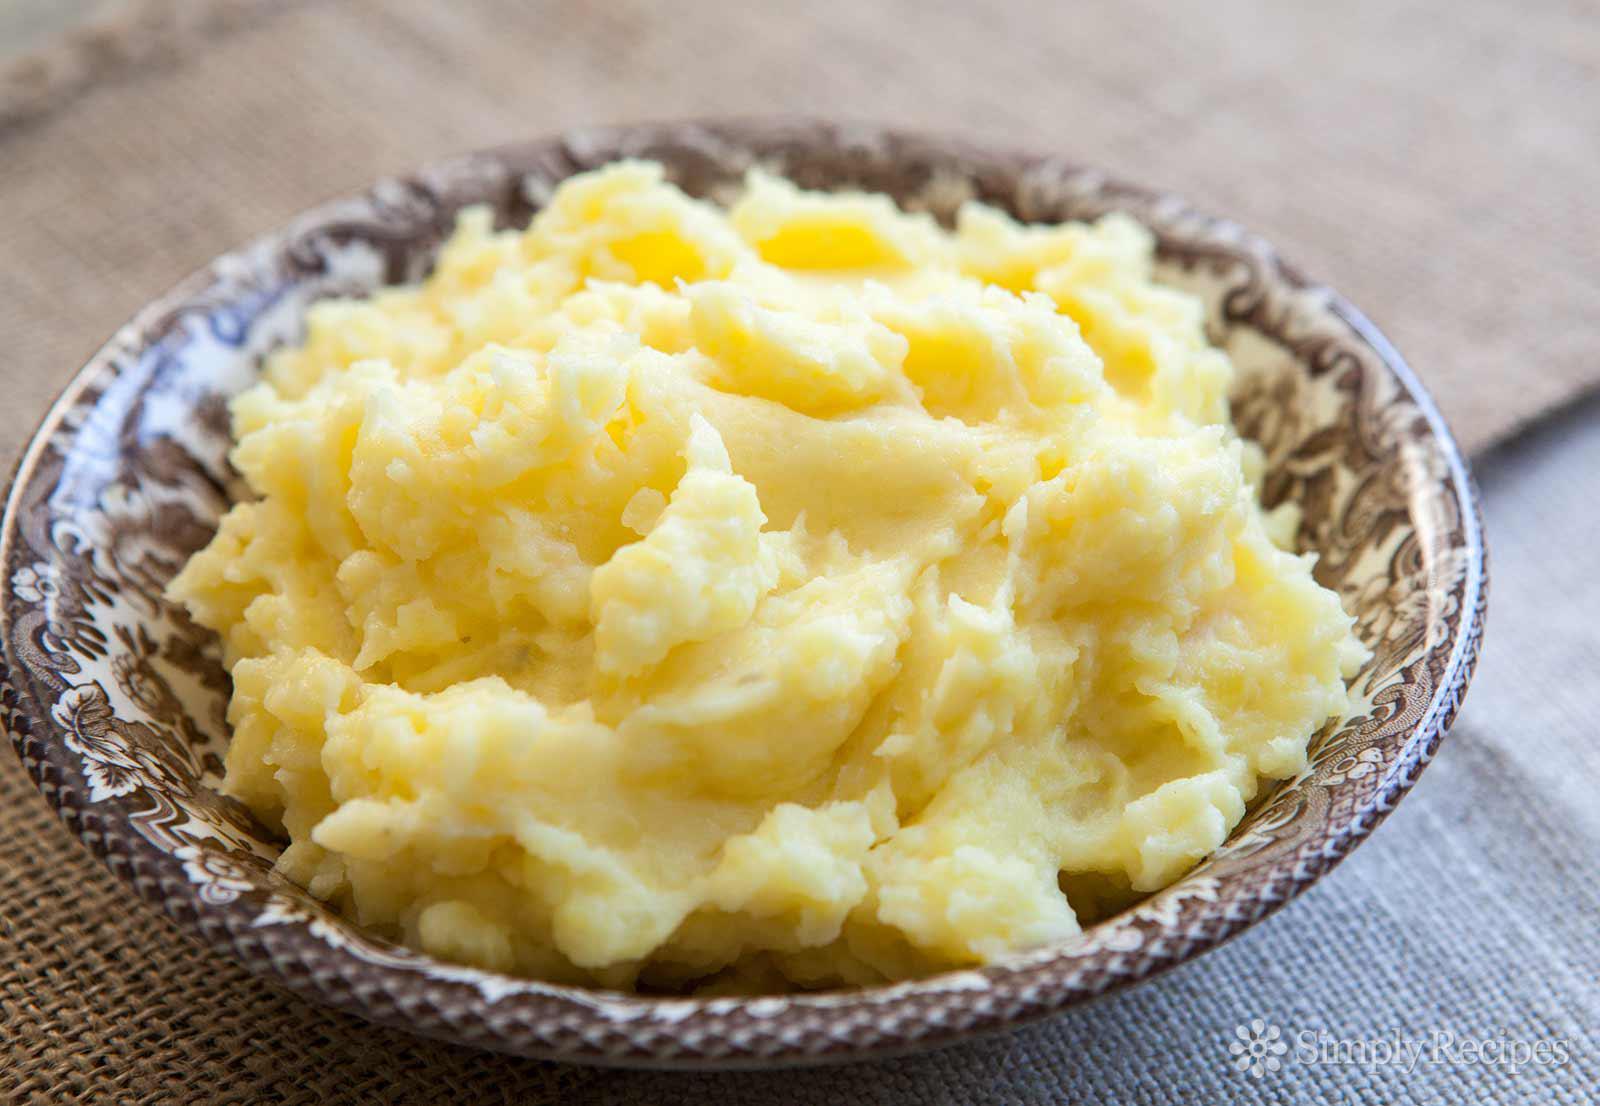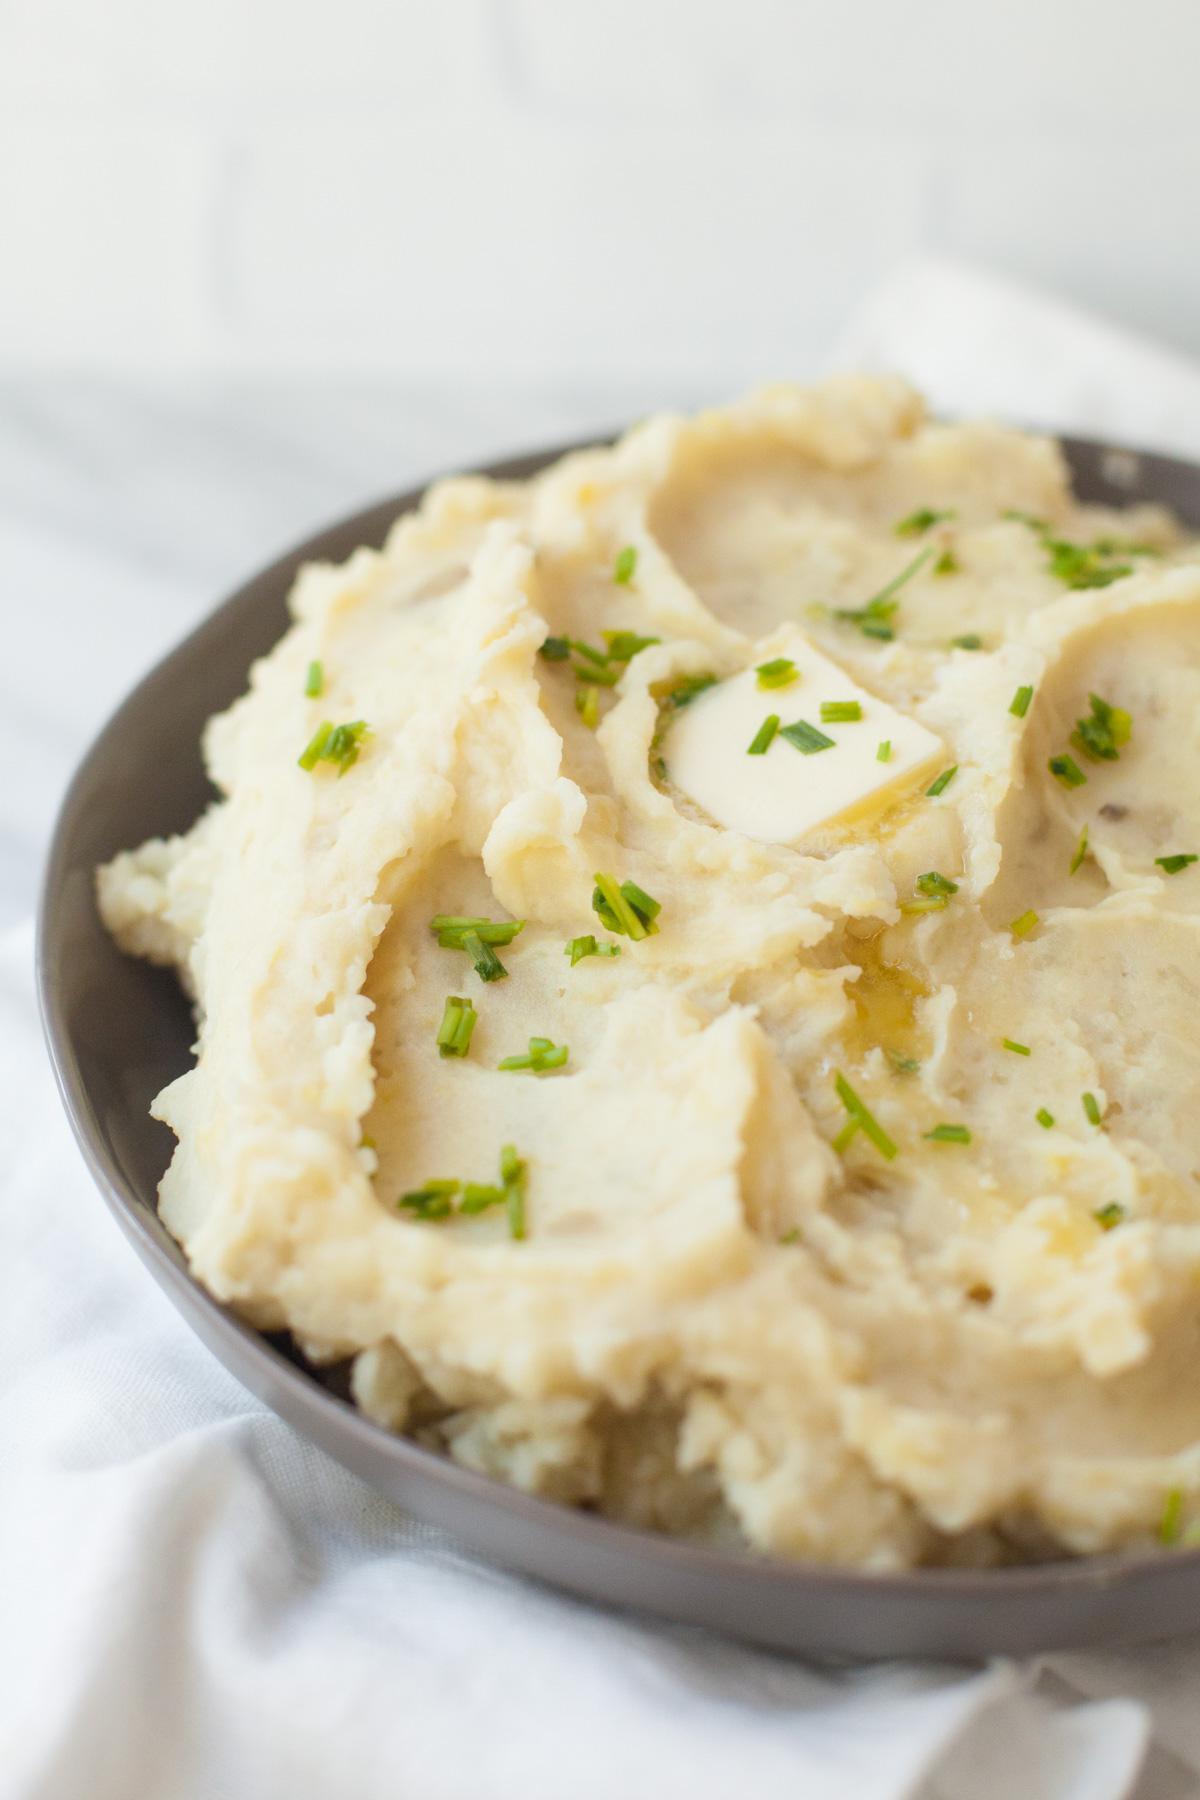The first image is the image on the left, the second image is the image on the right. Evaluate the accuracy of this statement regarding the images: "The potatoes in one of the images are served a grey bowl.". Is it true? Answer yes or no. Yes. The first image is the image on the left, the second image is the image on the right. Considering the images on both sides, is "One bowl of potatoes is ungarnished, and the other is topped with a sprinkling of chopped green bits." valid? Answer yes or no. Yes. 